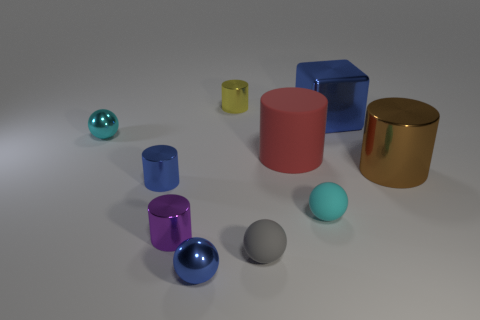Are there any patterns or unique features that stand out in this image? The image features a simplistic composition with no complex patterns, but the arrangement of the objects does create a pleasant visual flow. The reflective properties of the materials used for the spherical objects provide a unique feature, creating subtle highlights and reflections on their surfaces, which stands out against the matte nature of the other objects. 